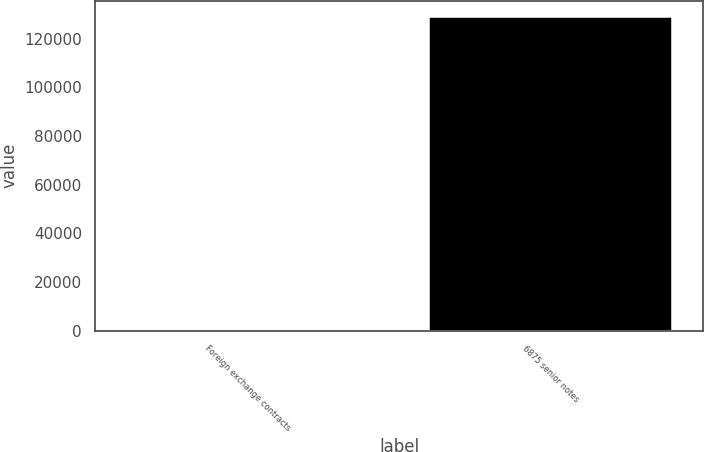<chart> <loc_0><loc_0><loc_500><loc_500><bar_chart><fcel>Foreign exchange contracts<fcel>6875 senior notes<nl><fcel>41<fcel>129000<nl></chart> 